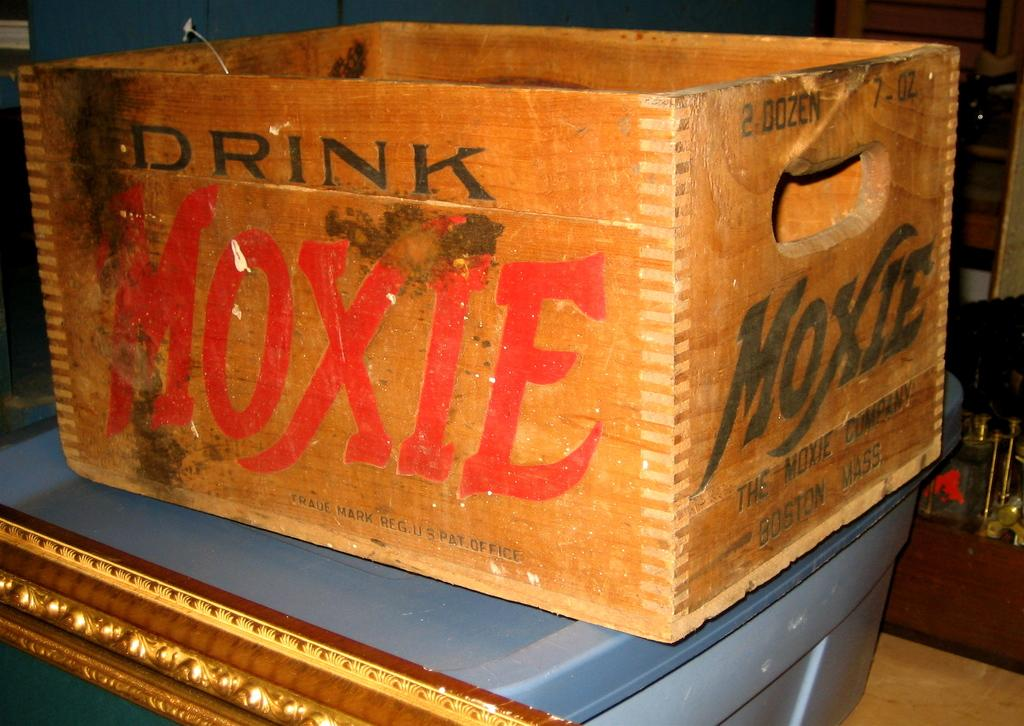What is the main object in the image? There is a wooden box in the image. Can you describe the position of the wooden box? The wooden box is kept on an object. What type of flowers can be seen growing in the throat of the wooden box in the image? There are no flowers present in the image, and the wooden box does not have a throat. 